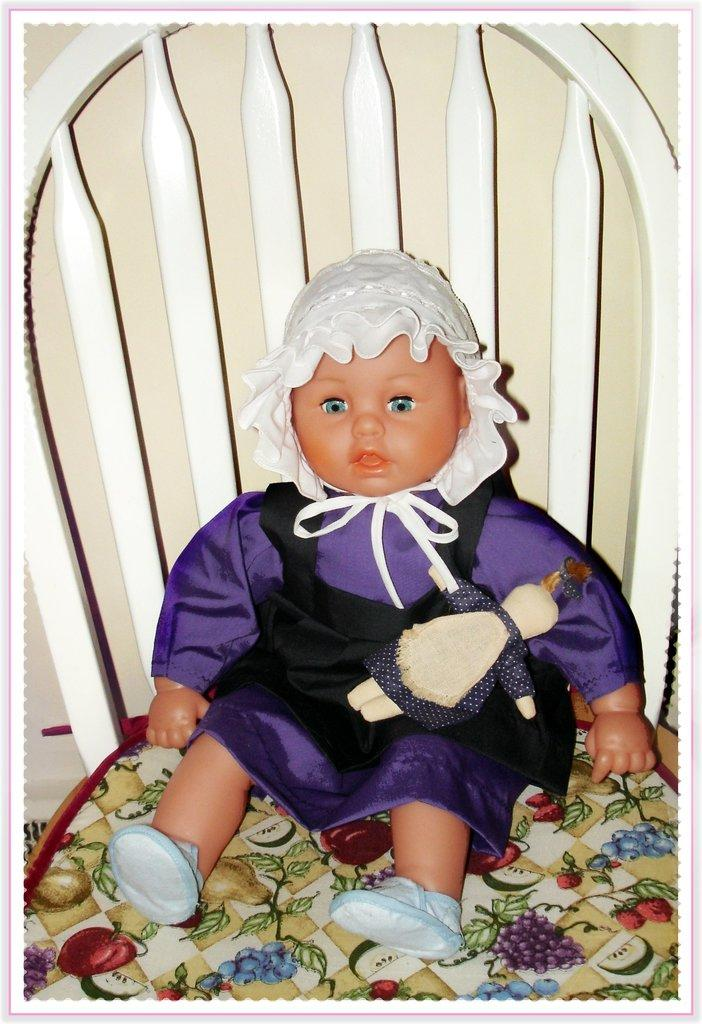What object can be seen in the image? There is a toy in the image. Where is the toy located? The toy is on a chair. What can be seen in the background of the image? There is a wall in the background of the image. What type of muscle is being exercised by the toy in the image? There is no muscle being exercised by the toy in the image, as it is an inanimate object. 